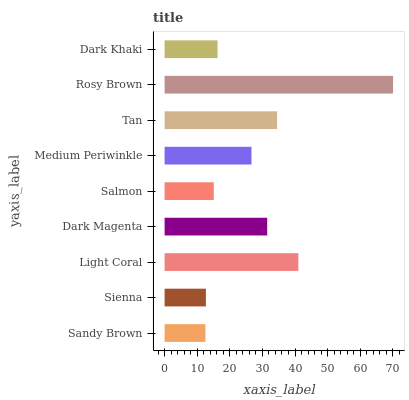Is Sandy Brown the minimum?
Answer yes or no. Yes. Is Rosy Brown the maximum?
Answer yes or no. Yes. Is Sienna the minimum?
Answer yes or no. No. Is Sienna the maximum?
Answer yes or no. No. Is Sienna greater than Sandy Brown?
Answer yes or no. Yes. Is Sandy Brown less than Sienna?
Answer yes or no. Yes. Is Sandy Brown greater than Sienna?
Answer yes or no. No. Is Sienna less than Sandy Brown?
Answer yes or no. No. Is Medium Periwinkle the high median?
Answer yes or no. Yes. Is Medium Periwinkle the low median?
Answer yes or no. Yes. Is Sienna the high median?
Answer yes or no. No. Is Dark Khaki the low median?
Answer yes or no. No. 